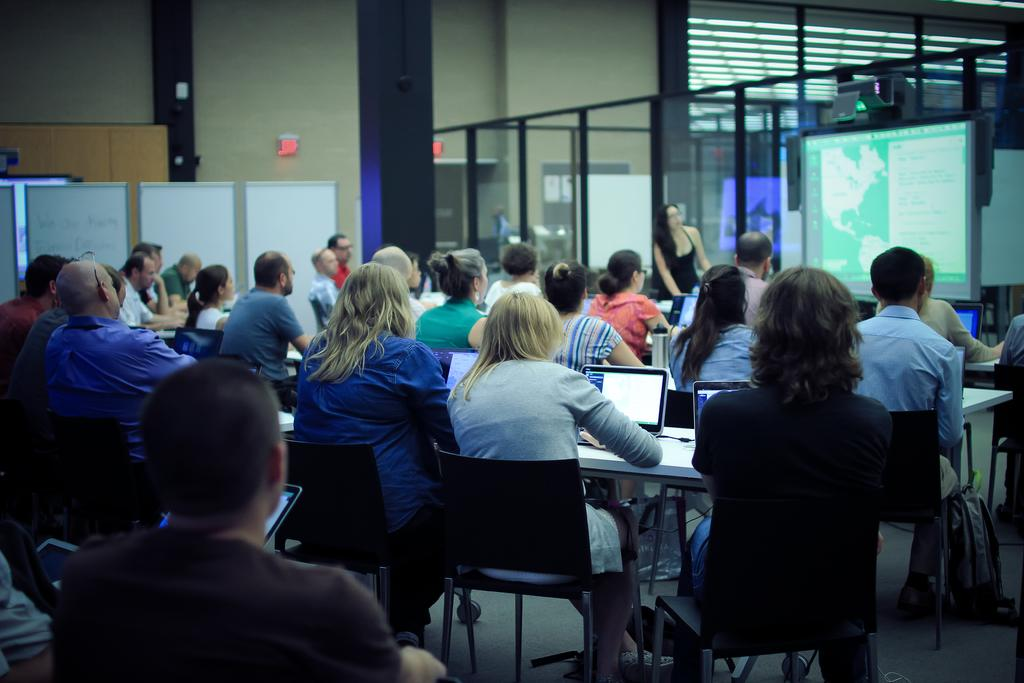What are the people in the image doing? The people in the image are sitting on chairs. Where are the chairs located in relation to the table? The chairs are near a table. What is on the table in the image? Laptops are placed on the table. What can be seen in the background of the image? There is a projector and glass doors visible in the background. What is on the wall in the background of the image? There is an exit board on the wall in the background. Can you see any boats or a lake in the image? No, there are no boats or a lake present in the image. 